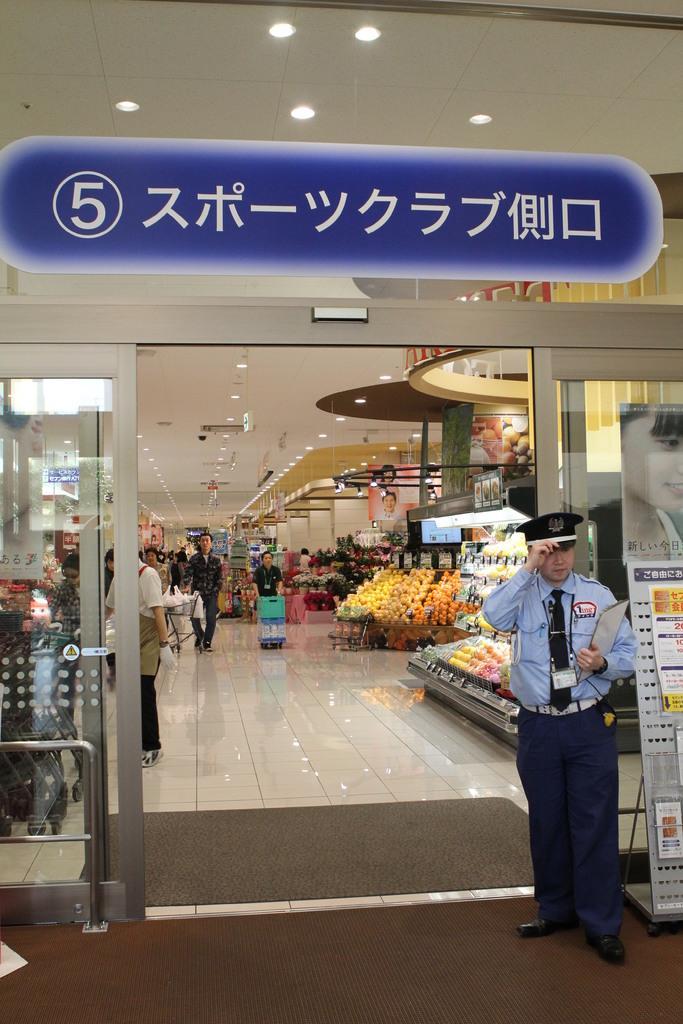Please provide a concise description of this image. In the picture we can see a store under it we can see many things are placed in the racks and some people are walking holding the trolley and to the ceiling we can see lights and outside the store we can see a security with uniform and top of the store we can see a name on blue color board. 